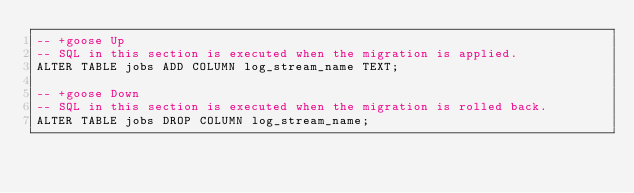<code> <loc_0><loc_0><loc_500><loc_500><_SQL_>-- +goose Up
-- SQL in this section is executed when the migration is applied.
ALTER TABLE jobs ADD COLUMN log_stream_name TEXT;

-- +goose Down
-- SQL in this section is executed when the migration is rolled back.
ALTER TABLE jobs DROP COLUMN log_stream_name;

</code> 